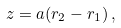Convert formula to latex. <formula><loc_0><loc_0><loc_500><loc_500>z = a ( r _ { 2 } - r _ { 1 } ) \, ,</formula> 